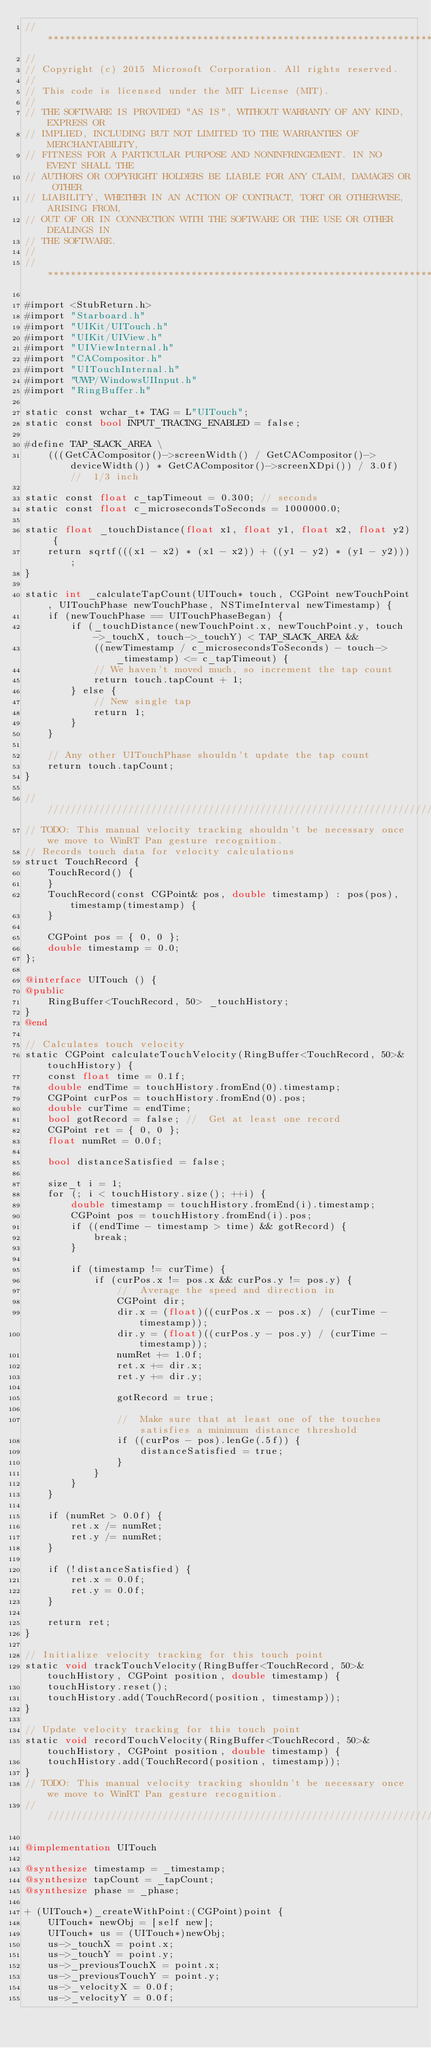<code> <loc_0><loc_0><loc_500><loc_500><_ObjectiveC_>//******************************************************************************
//
// Copyright (c) 2015 Microsoft Corporation. All rights reserved.
//
// This code is licensed under the MIT License (MIT).
//
// THE SOFTWARE IS PROVIDED "AS IS", WITHOUT WARRANTY OF ANY KIND, EXPRESS OR
// IMPLIED, INCLUDING BUT NOT LIMITED TO THE WARRANTIES OF MERCHANTABILITY,
// FITNESS FOR A PARTICULAR PURPOSE AND NONINFRINGEMENT. IN NO EVENT SHALL THE
// AUTHORS OR COPYRIGHT HOLDERS BE LIABLE FOR ANY CLAIM, DAMAGES OR OTHER
// LIABILITY, WHETHER IN AN ACTION OF CONTRACT, TORT OR OTHERWISE, ARISING FROM,
// OUT OF OR IN CONNECTION WITH THE SOFTWARE OR THE USE OR OTHER DEALINGS IN
// THE SOFTWARE.
//
//******************************************************************************

#import <StubReturn.h>
#import "Starboard.h"
#import "UIKit/UITouch.h"
#import "UIKit/UIView.h"
#import "UIViewInternal.h"
#import "CACompositor.h"
#import "UITouchInternal.h"
#import "UWP/WindowsUIInput.h"
#import "RingBuffer.h"

static const wchar_t* TAG = L"UITouch";
static const bool INPUT_TRACING_ENABLED = false;

#define TAP_SLACK_AREA \
    (((GetCACompositor()->screenWidth() / GetCACompositor()->deviceWidth()) * GetCACompositor()->screenXDpi()) / 3.0f) //  1/3 inch

static const float c_tapTimeout = 0.300; // seconds
static const float c_microsecondsToSeconds = 1000000.0;

static float _touchDistance(float x1, float y1, float x2, float y2) {
    return sqrtf(((x1 - x2) * (x1 - x2)) + ((y1 - y2) * (y1 - y2)));
}

static int _calculateTapCount(UITouch* touch, CGPoint newTouchPoint, UITouchPhase newTouchPhase, NSTimeInterval newTimestamp) {
    if (newTouchPhase == UITouchPhaseBegan) {
        if (_touchDistance(newTouchPoint.x, newTouchPoint.y, touch->_touchX, touch->_touchY) < TAP_SLACK_AREA &&
            ((newTimestamp / c_microsecondsToSeconds) - touch->_timestamp) <= c_tapTimeout) {
            // We haven't moved much, so increment the tap count
            return touch.tapCount + 1;
        } else {
            // New single tap
            return 1;
        }
    }

    // Any other UITouchPhase shouldn't update the tap count
    return touch.tapCount;
}

////////////////////////////////////////////////////////////////////////////////////////////////////////////
// TODO: This manual velocity tracking shouldn't be necessary once we move to WinRT Pan gesture recognition.
// Records touch data for velocity calculations
struct TouchRecord {
    TouchRecord() {
    }
    TouchRecord(const CGPoint& pos, double timestamp) : pos(pos), timestamp(timestamp) {
    }

    CGPoint pos = { 0, 0 };
    double timestamp = 0.0;
};

@interface UITouch () {
@public
    RingBuffer<TouchRecord, 50> _touchHistory;
}
@end

// Calculates touch velocity
static CGPoint calculateTouchVelocity(RingBuffer<TouchRecord, 50>& touchHistory) {
    const float time = 0.1f;
    double endTime = touchHistory.fromEnd(0).timestamp;
    CGPoint curPos = touchHistory.fromEnd(0).pos;
    double curTime = endTime;
    bool gotRecord = false; //  Get at least one record
    CGPoint ret = { 0, 0 };
    float numRet = 0.0f;

    bool distanceSatisfied = false;

    size_t i = 1;
    for (; i < touchHistory.size(); ++i) {
        double timestamp = touchHistory.fromEnd(i).timestamp;
        CGPoint pos = touchHistory.fromEnd(i).pos;
        if ((endTime - timestamp > time) && gotRecord) {
            break;
        }

        if (timestamp != curTime) {
            if (curPos.x != pos.x && curPos.y != pos.y) {
                //  Average the speed and direction in
                CGPoint dir;
                dir.x = (float)((curPos.x - pos.x) / (curTime - timestamp));
                dir.y = (float)((curPos.y - pos.y) / (curTime - timestamp));
                numRet += 1.0f;
                ret.x += dir.x;
                ret.y += dir.y;

                gotRecord = true;

                //  Make sure that at least one of the touches satisfies a minimum distance threshold
                if ((curPos - pos).lenGe(.5f)) {
                    distanceSatisfied = true;
                }
            }
        }
    }

    if (numRet > 0.0f) {
        ret.x /= numRet;
        ret.y /= numRet;
    }

    if (!distanceSatisfied) {
        ret.x = 0.0f;
        ret.y = 0.0f;
    }

    return ret;
}

// Initialize velocity tracking for this touch point
static void trackTouchVelocity(RingBuffer<TouchRecord, 50>& touchHistory, CGPoint position, double timestamp) {
    touchHistory.reset();
    touchHistory.add(TouchRecord(position, timestamp));
}

// Update velocity tracking for this touch point
static void recordTouchVelocity(RingBuffer<TouchRecord, 50>& touchHistory, CGPoint position, double timestamp) {
    touchHistory.add(TouchRecord(position, timestamp));
}
// TODO: This manual velocity tracking shouldn't be necessary once we move to WinRT Pan gesture recognition.
////////////////////////////////////////////////////////////////////////////////////////////////////////////

@implementation UITouch

@synthesize timestamp = _timestamp;
@synthesize tapCount = _tapCount;
@synthesize phase = _phase;

+ (UITouch*)_createWithPoint:(CGPoint)point {
    UITouch* newObj = [self new];
    UITouch* us = (UITouch*)newObj;
    us->_touchX = point.x;
    us->_touchY = point.y;
    us->_previousTouchX = point.x;
    us->_previousTouchY = point.y;
    us->_velocityX = 0.0f;
    us->_velocityY = 0.0f;</code> 